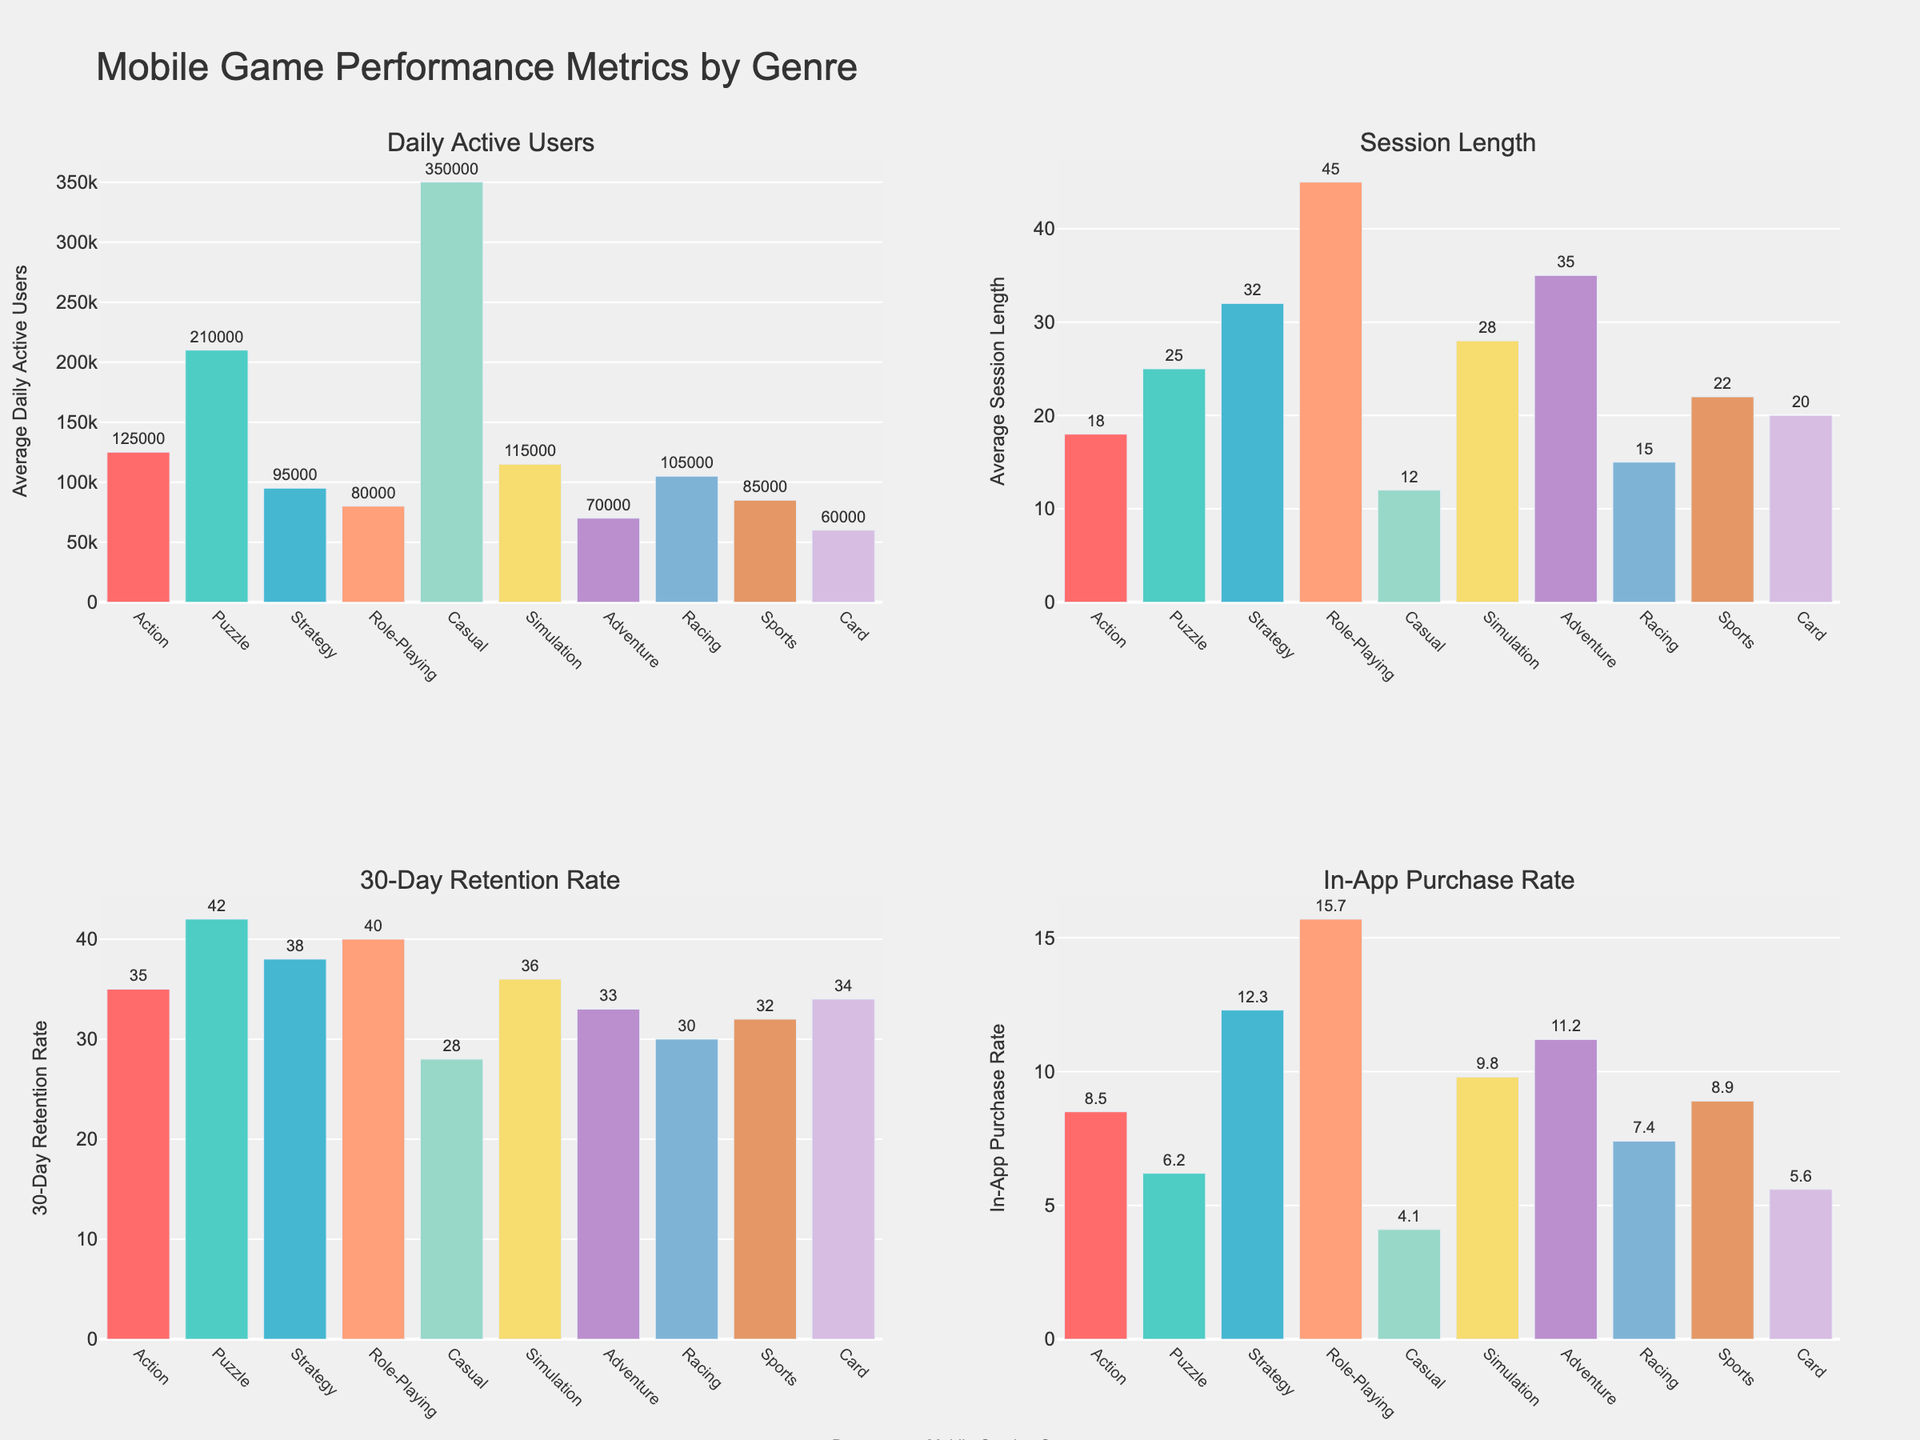what is the genre with the highest average daily active users? By looking at the bar height in the "Daily Active Users" subplot, the tallest bar represents the Casual genre. This means it has the highest average daily active users.
Answer: Casual Which genre has the longest average session length? The "Session Length" subplot shows that the longest bar is for the Role-Playing genre, indicating it has the highest average session length.
Answer: Role-Playing What’s the difference in the 30-Day Retention Rate between the Strategy and Action genres? The "30-Day Retention Rate" subplot shows that Strategy has a retention rate of 38% and Action has 35%. The difference is calculated as 38 - 35.
Answer: 3% How many genres have an in-app purchase rate greater than 10%? By observing the "In-App Purchase Rate" subplot, Role-Playing (15.7%), Strategy (12.3%), and Adventure (11.2%) all have rates above 10%. Counting these gives us the total number.
Answer: 3 Which genre has the lowest retention rate and what is its value? The "30-Day Retention Rate" subplot shows that the lowest bar belongs to Casual, which has a value of 28%.
Answer: Casual, 28% Does the Action genre have a higher average session length than the Racing genre? By comparing the bars in the "Session Length" subplot, Action has an average session length of 18 minutes and Racing has 15 minutes, so Action's session length is higher.
Answer: Yes What is the combined 30-day retention rate of the Puzzle and Card genres? The "30-Day Retention Rate" subplot has values for Puzzle at 42% and Card at 34%. Adding these together gives 42 + 34.
Answer: 76% Which genre has the highest percentage of in-app purchases, and what’s the percentage? The "In-App Purchase Rate" subplot shows the highest bar for Role-Playing, indicated by its value of 15.7%.
Answer: Role-Playing, 15.7% Compare the average session lengths of the Puzzle and Simulation genres. Which is longer and by how much? The "Session Length" subplot indicates Puzzle has a session length of 25 minutes and Simulation has 28 minutes. The difference is calculated as 28 - 25.
Answer: Simulation by 3 minutes What is the average daily active users for the genres with the three highest counts in this category? The "Daily Active Users" subplot shows the highest counts for Casual (350,000), Puzzle (210,000), and Action (125,000). The average is calculated as (350,000 + 210,000 + 125,000) / 3.
Answer: 228,333 